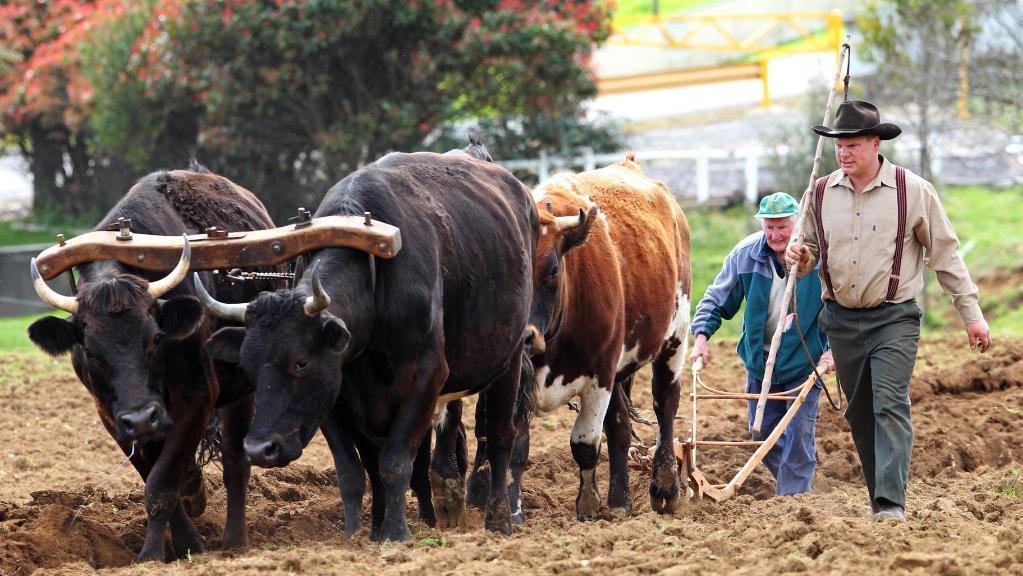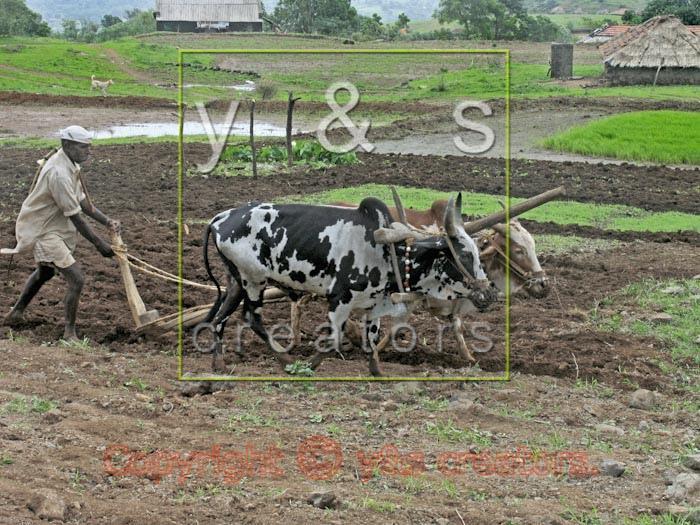The first image is the image on the left, the second image is the image on the right. For the images displayed, is the sentence "One image includes two spotted oxen pulling a plow, and the other image shows a plow team with at least two solid black oxen." factually correct? Answer yes or no. Yes. The first image is the image on the left, the second image is the image on the right. Given the left and right images, does the statement "In one of the images there are 2 people wearing a hat." hold true? Answer yes or no. Yes. 